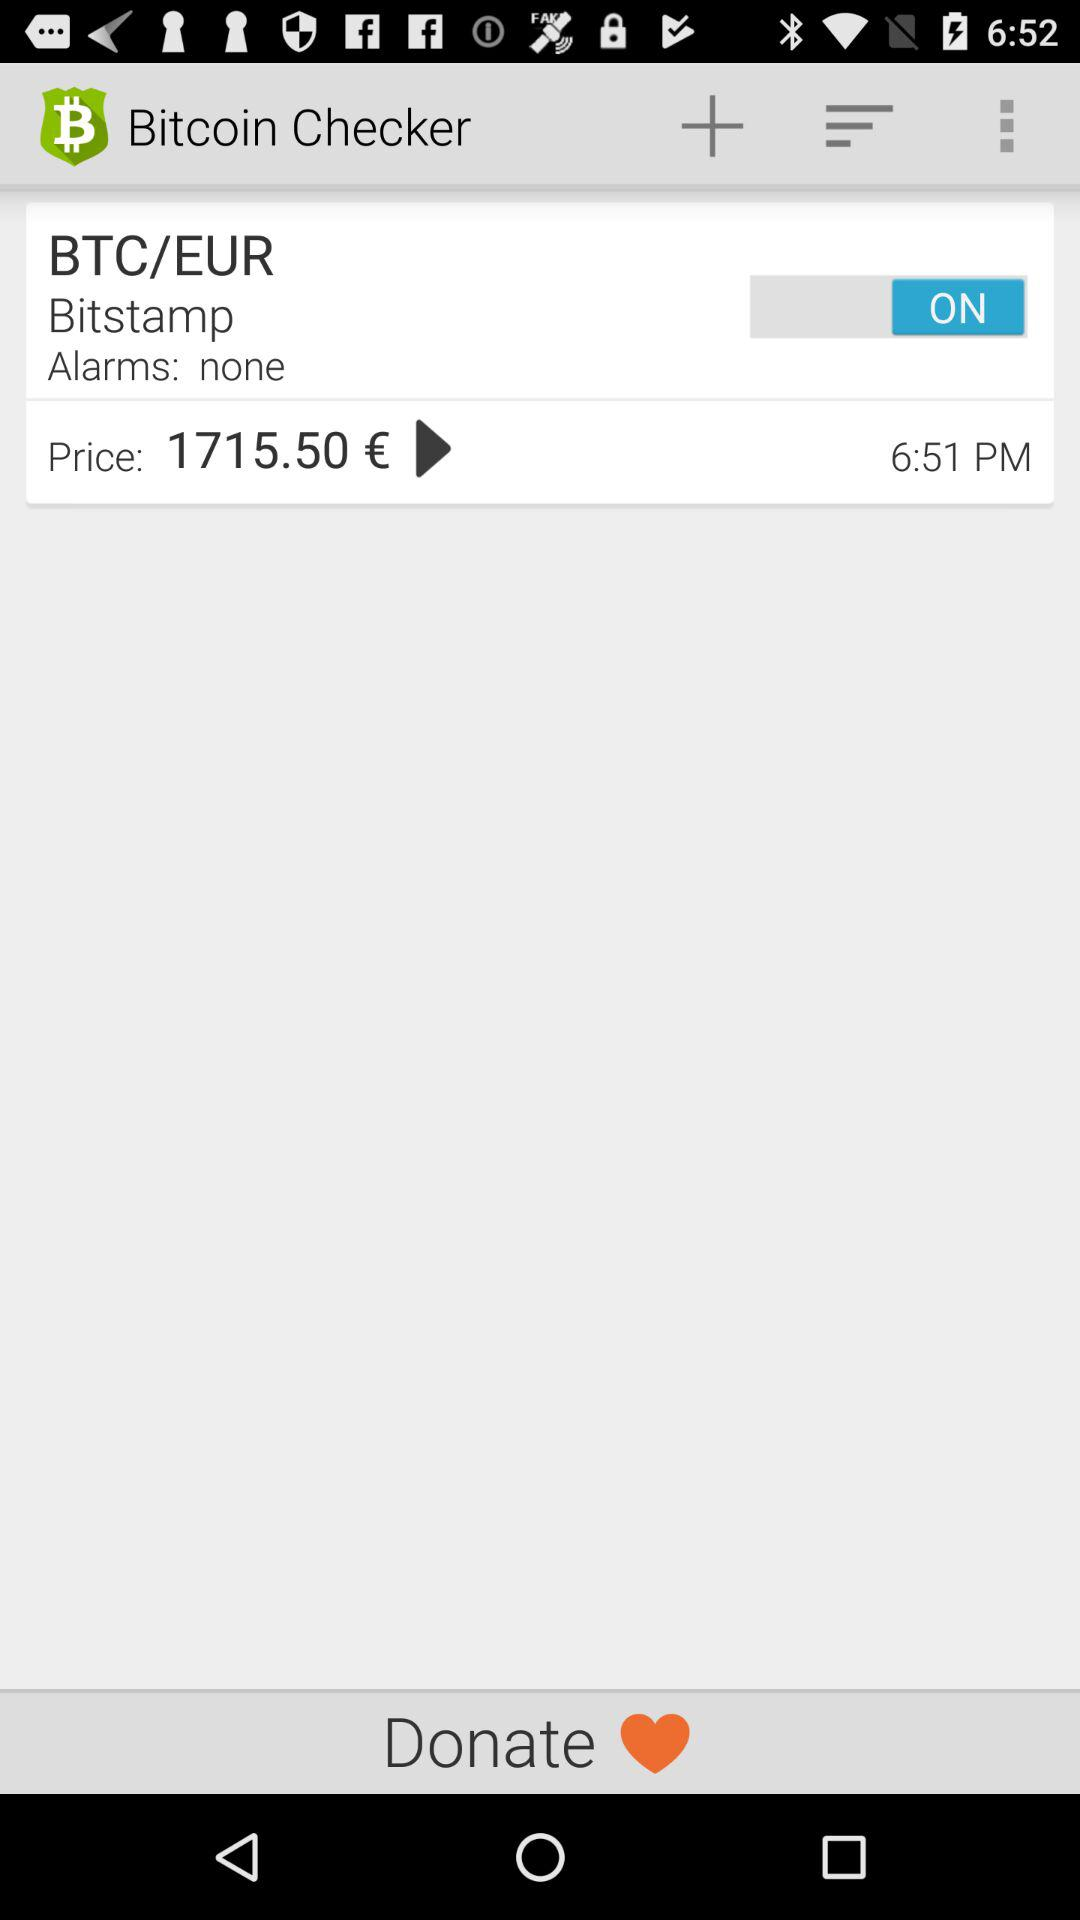What's the exchange rate of BTC/EUR? The exchange rate of BTC/EUR is €1715.50. 